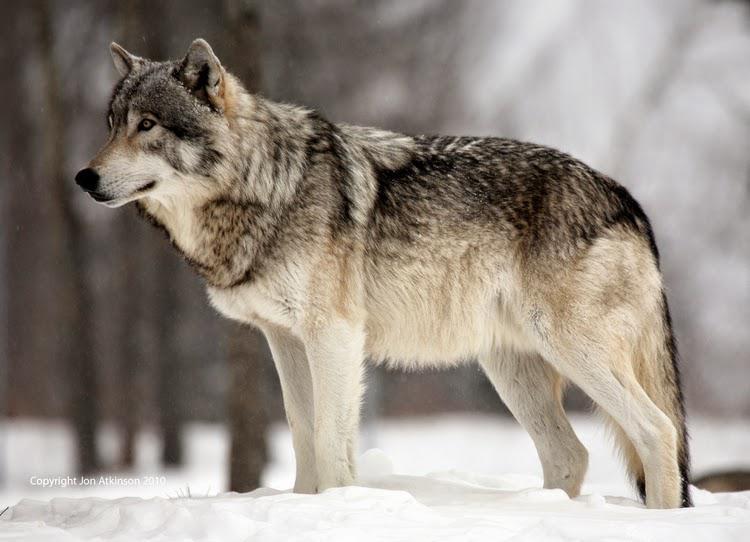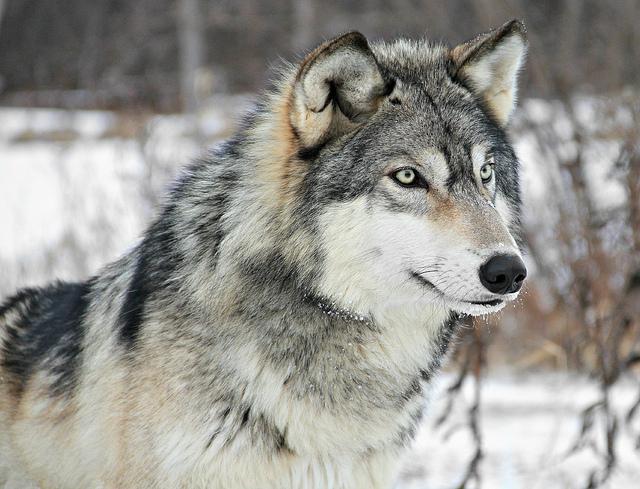The first image is the image on the left, the second image is the image on the right. For the images displayed, is the sentence "The left-hand image shows a wolf that is not standing on all fours." factually correct? Answer yes or no. No. 